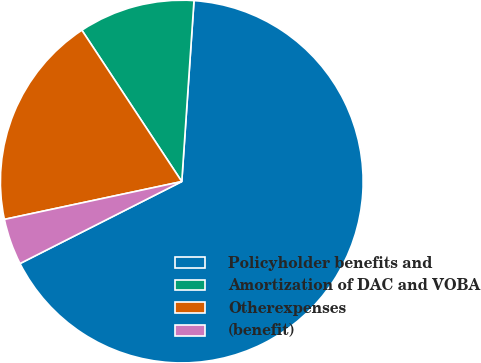Convert chart. <chart><loc_0><loc_0><loc_500><loc_500><pie_chart><fcel>Policyholder benefits and<fcel>Amortization of DAC and VOBA<fcel>Otherexpenses<fcel>(benefit)<nl><fcel>66.46%<fcel>10.36%<fcel>19.06%<fcel>4.12%<nl></chart> 